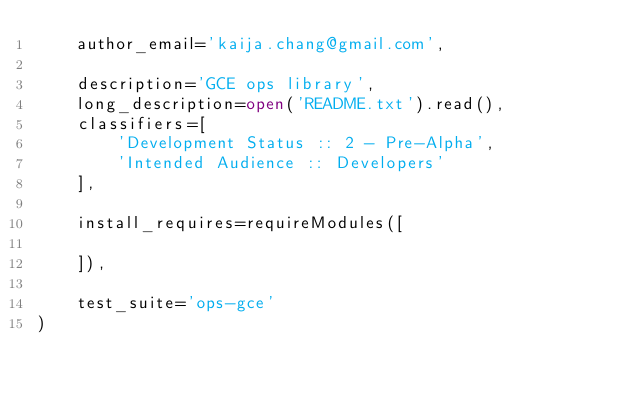<code> <loc_0><loc_0><loc_500><loc_500><_Python_>    author_email='kaija.chang@gmail.com',

    description='GCE ops library',
    long_description=open('README.txt').read(),
    classifiers=[
        'Development Status :: 2 - Pre-Alpha',
        'Intended Audience :: Developers'
    ],

    install_requires=requireModules([

    ]),

    test_suite='ops-gce'
)
</code> 